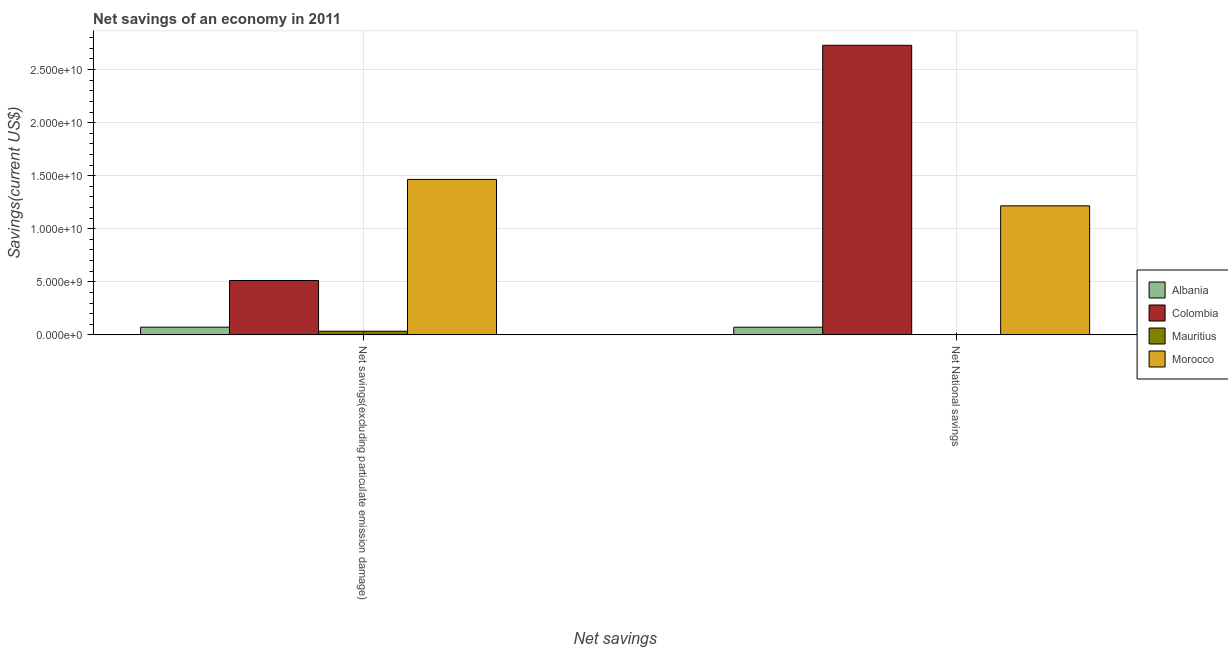How many different coloured bars are there?
Provide a succinct answer. 4. How many groups of bars are there?
Keep it short and to the point. 2. Are the number of bars per tick equal to the number of legend labels?
Provide a succinct answer. Yes. Are the number of bars on each tick of the X-axis equal?
Offer a terse response. Yes. How many bars are there on the 1st tick from the right?
Offer a very short reply. 4. What is the label of the 2nd group of bars from the left?
Your answer should be very brief. Net National savings. What is the net savings(excluding particulate emission damage) in Albania?
Keep it short and to the point. 7.27e+08. Across all countries, what is the maximum net savings(excluding particulate emission damage)?
Your response must be concise. 1.47e+1. Across all countries, what is the minimum net national savings?
Give a very brief answer. 2.38e+07. In which country was the net savings(excluding particulate emission damage) maximum?
Offer a terse response. Morocco. In which country was the net savings(excluding particulate emission damage) minimum?
Provide a short and direct response. Mauritius. What is the total net savings(excluding particulate emission damage) in the graph?
Offer a terse response. 2.08e+1. What is the difference between the net national savings in Mauritius and that in Morocco?
Ensure brevity in your answer.  -1.21e+1. What is the difference between the net savings(excluding particulate emission damage) in Morocco and the net national savings in Mauritius?
Provide a succinct answer. 1.46e+1. What is the average net national savings per country?
Offer a very short reply. 1.00e+1. What is the difference between the net savings(excluding particulate emission damage) and net national savings in Morocco?
Provide a short and direct response. 2.49e+09. What is the ratio of the net savings(excluding particulate emission damage) in Morocco to that in Mauritius?
Offer a very short reply. 42.3. What does the 3rd bar from the left in Net National savings represents?
Your answer should be compact. Mauritius. How many bars are there?
Your response must be concise. 8. How many countries are there in the graph?
Your answer should be compact. 4. Does the graph contain any zero values?
Make the answer very short. No. Does the graph contain grids?
Make the answer very short. Yes. Where does the legend appear in the graph?
Your answer should be very brief. Center right. How many legend labels are there?
Make the answer very short. 4. How are the legend labels stacked?
Offer a terse response. Vertical. What is the title of the graph?
Ensure brevity in your answer.  Net savings of an economy in 2011. Does "Dominica" appear as one of the legend labels in the graph?
Offer a terse response. No. What is the label or title of the X-axis?
Provide a short and direct response. Net savings. What is the label or title of the Y-axis?
Offer a terse response. Savings(current US$). What is the Savings(current US$) in Albania in Net savings(excluding particulate emission damage)?
Keep it short and to the point. 7.27e+08. What is the Savings(current US$) of Colombia in Net savings(excluding particulate emission damage)?
Give a very brief answer. 5.12e+09. What is the Savings(current US$) in Mauritius in Net savings(excluding particulate emission damage)?
Give a very brief answer. 3.46e+08. What is the Savings(current US$) of Morocco in Net savings(excluding particulate emission damage)?
Your response must be concise. 1.47e+1. What is the Savings(current US$) in Albania in Net National savings?
Your answer should be compact. 7.25e+08. What is the Savings(current US$) in Colombia in Net National savings?
Your response must be concise. 2.73e+1. What is the Savings(current US$) of Mauritius in Net National savings?
Offer a terse response. 2.38e+07. What is the Savings(current US$) of Morocco in Net National savings?
Your response must be concise. 1.22e+1. Across all Net savings, what is the maximum Savings(current US$) in Albania?
Your response must be concise. 7.27e+08. Across all Net savings, what is the maximum Savings(current US$) of Colombia?
Your response must be concise. 2.73e+1. Across all Net savings, what is the maximum Savings(current US$) in Mauritius?
Your answer should be compact. 3.46e+08. Across all Net savings, what is the maximum Savings(current US$) of Morocco?
Keep it short and to the point. 1.47e+1. Across all Net savings, what is the minimum Savings(current US$) in Albania?
Keep it short and to the point. 7.25e+08. Across all Net savings, what is the minimum Savings(current US$) of Colombia?
Make the answer very short. 5.12e+09. Across all Net savings, what is the minimum Savings(current US$) in Mauritius?
Your answer should be very brief. 2.38e+07. Across all Net savings, what is the minimum Savings(current US$) of Morocco?
Your response must be concise. 1.22e+1. What is the total Savings(current US$) in Albania in the graph?
Keep it short and to the point. 1.45e+09. What is the total Savings(current US$) of Colombia in the graph?
Offer a terse response. 3.24e+1. What is the total Savings(current US$) in Mauritius in the graph?
Provide a succinct answer. 3.70e+08. What is the total Savings(current US$) of Morocco in the graph?
Give a very brief answer. 2.68e+1. What is the difference between the Savings(current US$) in Albania in Net savings(excluding particulate emission damage) and that in Net National savings?
Keep it short and to the point. 2.20e+06. What is the difference between the Savings(current US$) in Colombia in Net savings(excluding particulate emission damage) and that in Net National savings?
Your response must be concise. -2.22e+1. What is the difference between the Savings(current US$) of Mauritius in Net savings(excluding particulate emission damage) and that in Net National savings?
Provide a succinct answer. 3.23e+08. What is the difference between the Savings(current US$) in Morocco in Net savings(excluding particulate emission damage) and that in Net National savings?
Your answer should be very brief. 2.49e+09. What is the difference between the Savings(current US$) of Albania in Net savings(excluding particulate emission damage) and the Savings(current US$) of Colombia in Net National savings?
Offer a very short reply. -2.66e+1. What is the difference between the Savings(current US$) of Albania in Net savings(excluding particulate emission damage) and the Savings(current US$) of Mauritius in Net National savings?
Keep it short and to the point. 7.03e+08. What is the difference between the Savings(current US$) of Albania in Net savings(excluding particulate emission damage) and the Savings(current US$) of Morocco in Net National savings?
Your response must be concise. -1.14e+1. What is the difference between the Savings(current US$) of Colombia in Net savings(excluding particulate emission damage) and the Savings(current US$) of Mauritius in Net National savings?
Ensure brevity in your answer.  5.10e+09. What is the difference between the Savings(current US$) in Colombia in Net savings(excluding particulate emission damage) and the Savings(current US$) in Morocco in Net National savings?
Keep it short and to the point. -7.04e+09. What is the difference between the Savings(current US$) of Mauritius in Net savings(excluding particulate emission damage) and the Savings(current US$) of Morocco in Net National savings?
Ensure brevity in your answer.  -1.18e+1. What is the average Savings(current US$) of Albania per Net savings?
Your response must be concise. 7.26e+08. What is the average Savings(current US$) of Colombia per Net savings?
Offer a terse response. 1.62e+1. What is the average Savings(current US$) of Mauritius per Net savings?
Ensure brevity in your answer.  1.85e+08. What is the average Savings(current US$) in Morocco per Net savings?
Your answer should be compact. 1.34e+1. What is the difference between the Savings(current US$) of Albania and Savings(current US$) of Colombia in Net savings(excluding particulate emission damage)?
Provide a succinct answer. -4.40e+09. What is the difference between the Savings(current US$) in Albania and Savings(current US$) in Mauritius in Net savings(excluding particulate emission damage)?
Provide a succinct answer. 3.81e+08. What is the difference between the Savings(current US$) in Albania and Savings(current US$) in Morocco in Net savings(excluding particulate emission damage)?
Give a very brief answer. -1.39e+1. What is the difference between the Savings(current US$) of Colombia and Savings(current US$) of Mauritius in Net savings(excluding particulate emission damage)?
Offer a terse response. 4.78e+09. What is the difference between the Savings(current US$) in Colombia and Savings(current US$) in Morocco in Net savings(excluding particulate emission damage)?
Make the answer very short. -9.53e+09. What is the difference between the Savings(current US$) of Mauritius and Savings(current US$) of Morocco in Net savings(excluding particulate emission damage)?
Your response must be concise. -1.43e+1. What is the difference between the Savings(current US$) in Albania and Savings(current US$) in Colombia in Net National savings?
Make the answer very short. -2.66e+1. What is the difference between the Savings(current US$) in Albania and Savings(current US$) in Mauritius in Net National savings?
Keep it short and to the point. 7.01e+08. What is the difference between the Savings(current US$) of Albania and Savings(current US$) of Morocco in Net National savings?
Give a very brief answer. -1.14e+1. What is the difference between the Savings(current US$) of Colombia and Savings(current US$) of Mauritius in Net National savings?
Give a very brief answer. 2.73e+1. What is the difference between the Savings(current US$) of Colombia and Savings(current US$) of Morocco in Net National savings?
Keep it short and to the point. 1.51e+1. What is the difference between the Savings(current US$) of Mauritius and Savings(current US$) of Morocco in Net National savings?
Your response must be concise. -1.21e+1. What is the ratio of the Savings(current US$) of Albania in Net savings(excluding particulate emission damage) to that in Net National savings?
Your response must be concise. 1. What is the ratio of the Savings(current US$) in Colombia in Net savings(excluding particulate emission damage) to that in Net National savings?
Provide a short and direct response. 0.19. What is the ratio of the Savings(current US$) of Mauritius in Net savings(excluding particulate emission damage) to that in Net National savings?
Offer a very short reply. 14.56. What is the ratio of the Savings(current US$) of Morocco in Net savings(excluding particulate emission damage) to that in Net National savings?
Offer a very short reply. 1.2. What is the difference between the highest and the second highest Savings(current US$) of Albania?
Provide a short and direct response. 2.20e+06. What is the difference between the highest and the second highest Savings(current US$) in Colombia?
Keep it short and to the point. 2.22e+1. What is the difference between the highest and the second highest Savings(current US$) of Mauritius?
Provide a succinct answer. 3.23e+08. What is the difference between the highest and the second highest Savings(current US$) of Morocco?
Your answer should be very brief. 2.49e+09. What is the difference between the highest and the lowest Savings(current US$) in Albania?
Offer a terse response. 2.20e+06. What is the difference between the highest and the lowest Savings(current US$) in Colombia?
Your answer should be compact. 2.22e+1. What is the difference between the highest and the lowest Savings(current US$) of Mauritius?
Offer a very short reply. 3.23e+08. What is the difference between the highest and the lowest Savings(current US$) of Morocco?
Offer a terse response. 2.49e+09. 